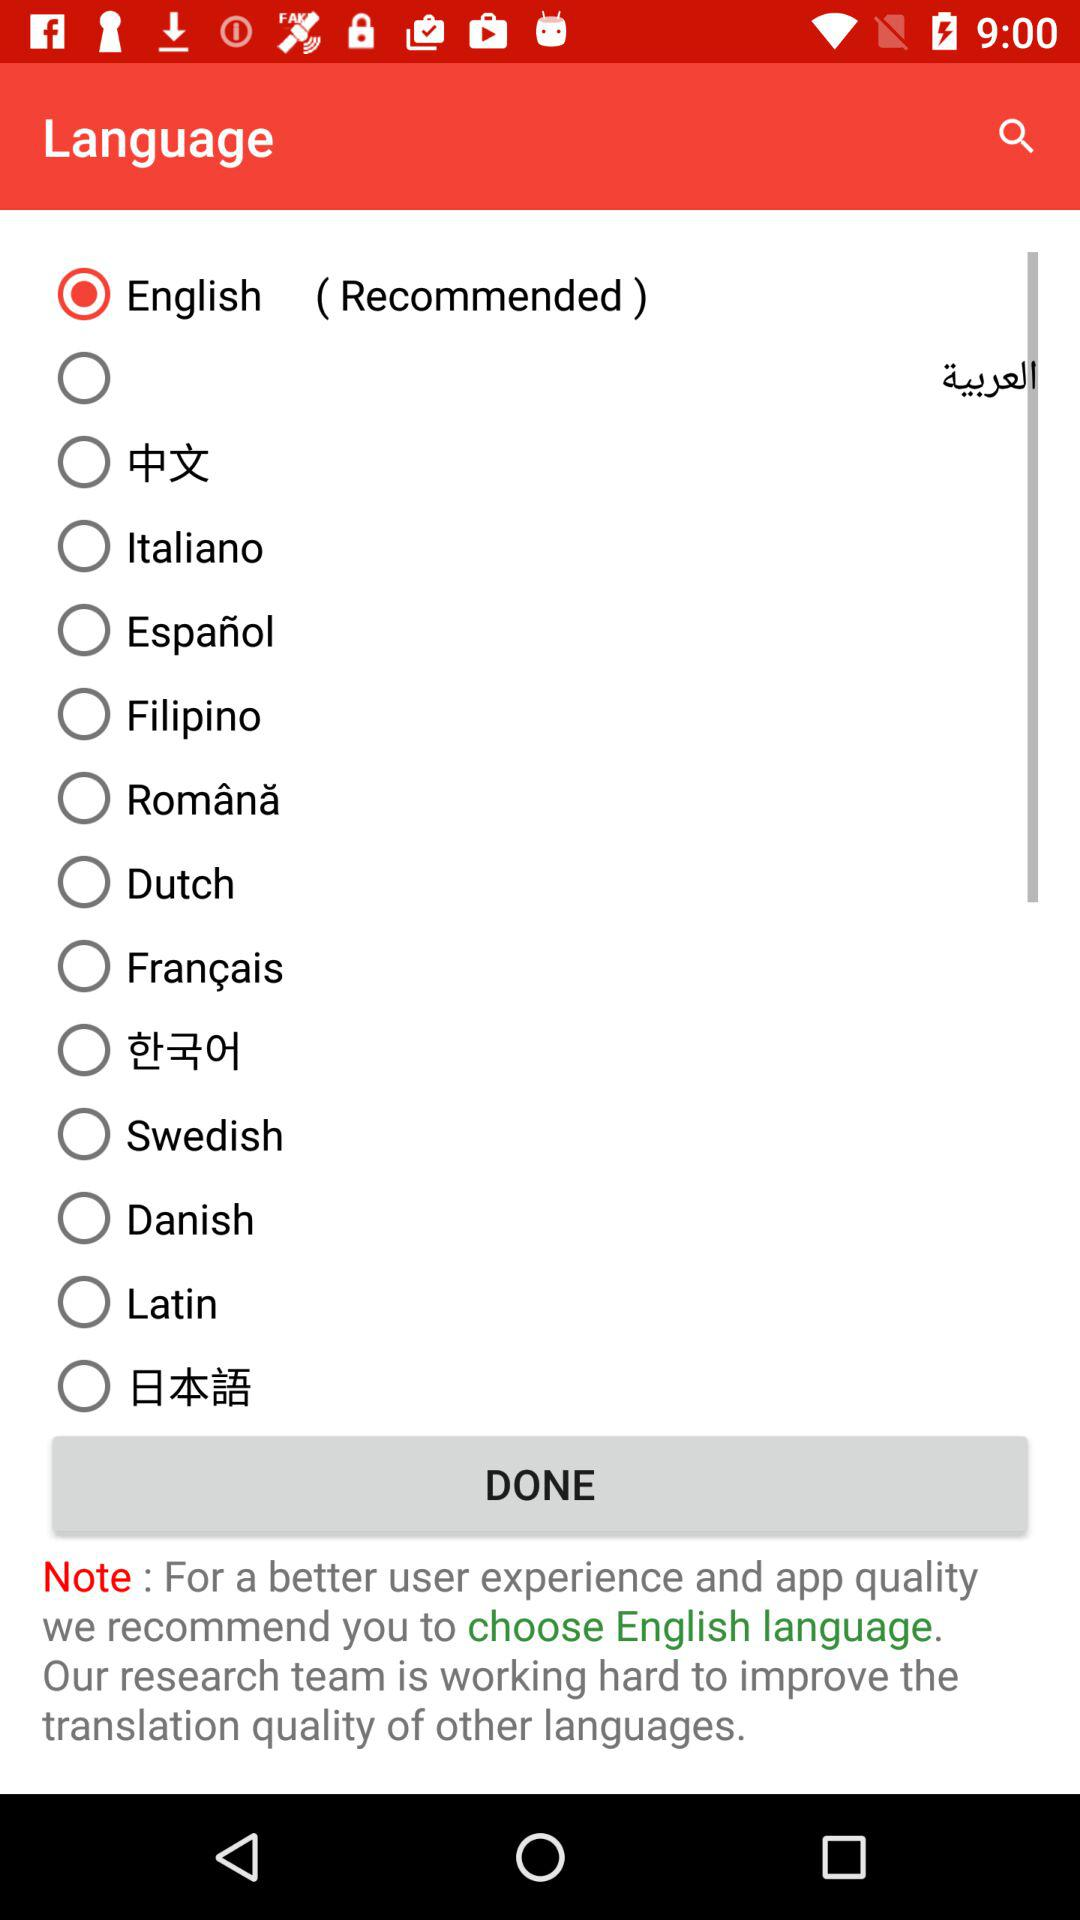Who is this application powered by?
When the provided information is insufficient, respond with <no answer>. <no answer> 